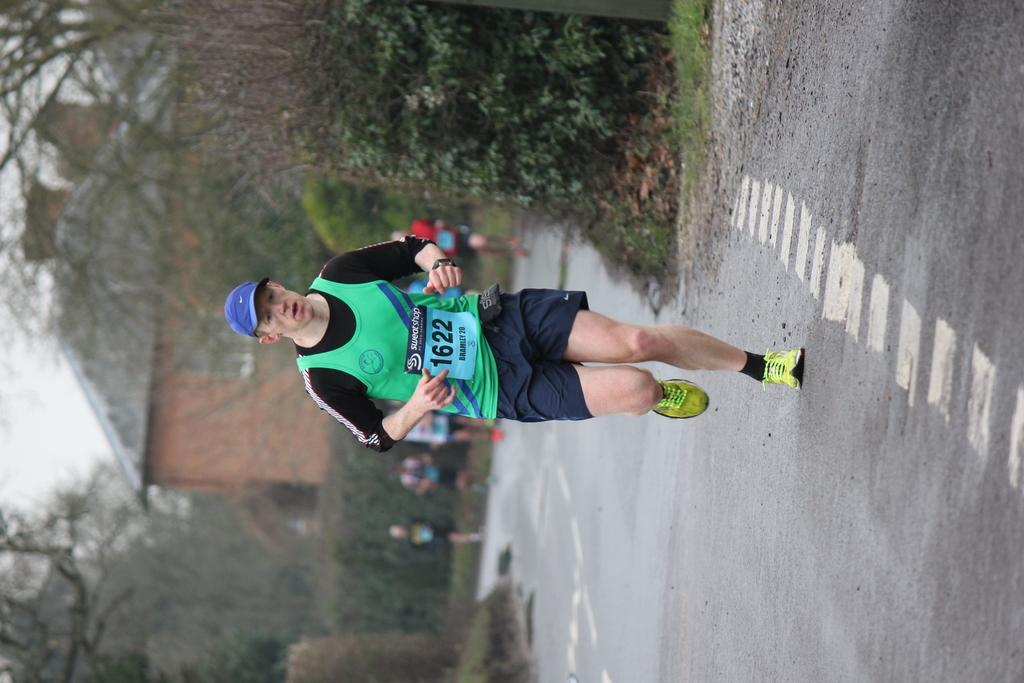Please provide a concise description of this image. In this image I can see a person wearing black, green and blue colored dress is standing on the road. In the background I can see few other persons, few trees, a building and the sky. 